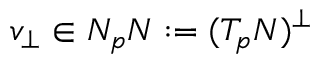Convert formula to latex. <formula><loc_0><loc_0><loc_500><loc_500>v _ { \perp } \in N _ { p } N \colon = ( T _ { p } N ) ^ { \perp }</formula> 